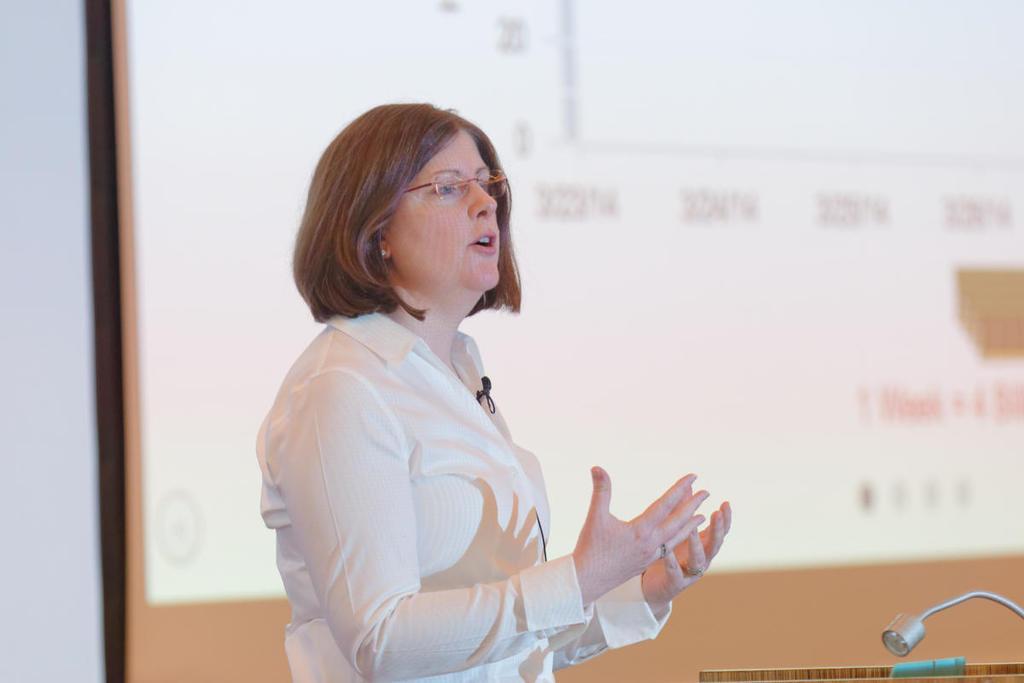Could you give a brief overview of what you see in this image? There is a woman in white color shirt, wearing a mic and speaking on a stage in front of stand, which is having a mic. In the background, there is a screen, near white wall. 